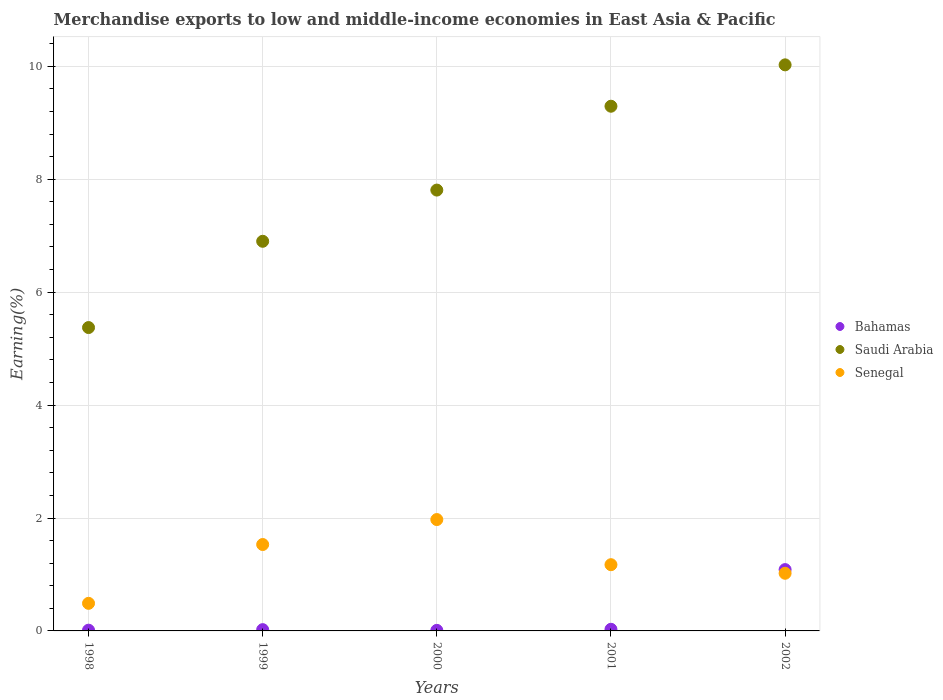Is the number of dotlines equal to the number of legend labels?
Provide a succinct answer. Yes. What is the percentage of amount earned from merchandise exports in Saudi Arabia in 2002?
Keep it short and to the point. 10.03. Across all years, what is the maximum percentage of amount earned from merchandise exports in Senegal?
Provide a succinct answer. 1.97. Across all years, what is the minimum percentage of amount earned from merchandise exports in Bahamas?
Give a very brief answer. 0.01. In which year was the percentage of amount earned from merchandise exports in Senegal minimum?
Your answer should be very brief. 1998. What is the total percentage of amount earned from merchandise exports in Bahamas in the graph?
Give a very brief answer. 1.16. What is the difference between the percentage of amount earned from merchandise exports in Bahamas in 1998 and that in 2002?
Keep it short and to the point. -1.07. What is the difference between the percentage of amount earned from merchandise exports in Bahamas in 2002 and the percentage of amount earned from merchandise exports in Saudi Arabia in 1999?
Provide a succinct answer. -5.81. What is the average percentage of amount earned from merchandise exports in Saudi Arabia per year?
Provide a succinct answer. 7.88. In the year 1999, what is the difference between the percentage of amount earned from merchandise exports in Saudi Arabia and percentage of amount earned from merchandise exports in Bahamas?
Offer a very short reply. 6.88. In how many years, is the percentage of amount earned from merchandise exports in Bahamas greater than 7.6 %?
Provide a succinct answer. 0. What is the ratio of the percentage of amount earned from merchandise exports in Senegal in 1999 to that in 2000?
Keep it short and to the point. 0.78. What is the difference between the highest and the second highest percentage of amount earned from merchandise exports in Senegal?
Your answer should be compact. 0.44. What is the difference between the highest and the lowest percentage of amount earned from merchandise exports in Senegal?
Make the answer very short. 1.48. In how many years, is the percentage of amount earned from merchandise exports in Bahamas greater than the average percentage of amount earned from merchandise exports in Bahamas taken over all years?
Provide a short and direct response. 1. Is the sum of the percentage of amount earned from merchandise exports in Senegal in 1998 and 2000 greater than the maximum percentage of amount earned from merchandise exports in Saudi Arabia across all years?
Provide a succinct answer. No. Does the percentage of amount earned from merchandise exports in Bahamas monotonically increase over the years?
Your response must be concise. No. Is the percentage of amount earned from merchandise exports in Senegal strictly greater than the percentage of amount earned from merchandise exports in Bahamas over the years?
Your answer should be compact. No. How many dotlines are there?
Make the answer very short. 3. How many years are there in the graph?
Provide a short and direct response. 5. What is the difference between two consecutive major ticks on the Y-axis?
Your response must be concise. 2. Does the graph contain grids?
Your answer should be very brief. Yes. Where does the legend appear in the graph?
Ensure brevity in your answer.  Center right. How many legend labels are there?
Offer a very short reply. 3. What is the title of the graph?
Offer a very short reply. Merchandise exports to low and middle-income economies in East Asia & Pacific. What is the label or title of the X-axis?
Keep it short and to the point. Years. What is the label or title of the Y-axis?
Ensure brevity in your answer.  Earning(%). What is the Earning(%) in Bahamas in 1998?
Provide a short and direct response. 0.01. What is the Earning(%) in Saudi Arabia in 1998?
Your response must be concise. 5.37. What is the Earning(%) in Senegal in 1998?
Provide a succinct answer. 0.49. What is the Earning(%) in Bahamas in 1999?
Make the answer very short. 0.02. What is the Earning(%) in Saudi Arabia in 1999?
Provide a short and direct response. 6.9. What is the Earning(%) of Senegal in 1999?
Provide a short and direct response. 1.53. What is the Earning(%) of Bahamas in 2000?
Provide a succinct answer. 0.01. What is the Earning(%) in Saudi Arabia in 2000?
Offer a terse response. 7.81. What is the Earning(%) of Senegal in 2000?
Ensure brevity in your answer.  1.97. What is the Earning(%) of Bahamas in 2001?
Your response must be concise. 0.03. What is the Earning(%) of Saudi Arabia in 2001?
Make the answer very short. 9.29. What is the Earning(%) in Senegal in 2001?
Your answer should be compact. 1.17. What is the Earning(%) of Bahamas in 2002?
Ensure brevity in your answer.  1.09. What is the Earning(%) of Saudi Arabia in 2002?
Your answer should be very brief. 10.03. What is the Earning(%) in Senegal in 2002?
Provide a succinct answer. 1.02. Across all years, what is the maximum Earning(%) of Bahamas?
Provide a succinct answer. 1.09. Across all years, what is the maximum Earning(%) of Saudi Arabia?
Provide a succinct answer. 10.03. Across all years, what is the maximum Earning(%) in Senegal?
Offer a very short reply. 1.97. Across all years, what is the minimum Earning(%) of Bahamas?
Offer a terse response. 0.01. Across all years, what is the minimum Earning(%) of Saudi Arabia?
Provide a succinct answer. 5.37. Across all years, what is the minimum Earning(%) of Senegal?
Your answer should be very brief. 0.49. What is the total Earning(%) of Bahamas in the graph?
Give a very brief answer. 1.16. What is the total Earning(%) of Saudi Arabia in the graph?
Ensure brevity in your answer.  39.4. What is the total Earning(%) of Senegal in the graph?
Keep it short and to the point. 6.19. What is the difference between the Earning(%) of Bahamas in 1998 and that in 1999?
Ensure brevity in your answer.  -0.01. What is the difference between the Earning(%) in Saudi Arabia in 1998 and that in 1999?
Keep it short and to the point. -1.53. What is the difference between the Earning(%) in Senegal in 1998 and that in 1999?
Offer a terse response. -1.04. What is the difference between the Earning(%) in Bahamas in 1998 and that in 2000?
Your answer should be compact. 0. What is the difference between the Earning(%) of Saudi Arabia in 1998 and that in 2000?
Provide a succinct answer. -2.43. What is the difference between the Earning(%) of Senegal in 1998 and that in 2000?
Keep it short and to the point. -1.48. What is the difference between the Earning(%) of Bahamas in 1998 and that in 2001?
Give a very brief answer. -0.02. What is the difference between the Earning(%) in Saudi Arabia in 1998 and that in 2001?
Give a very brief answer. -3.92. What is the difference between the Earning(%) in Senegal in 1998 and that in 2001?
Offer a terse response. -0.68. What is the difference between the Earning(%) in Bahamas in 1998 and that in 2002?
Offer a terse response. -1.07. What is the difference between the Earning(%) in Saudi Arabia in 1998 and that in 2002?
Provide a short and direct response. -4.65. What is the difference between the Earning(%) in Senegal in 1998 and that in 2002?
Make the answer very short. -0.53. What is the difference between the Earning(%) in Bahamas in 1999 and that in 2000?
Provide a succinct answer. 0.01. What is the difference between the Earning(%) of Saudi Arabia in 1999 and that in 2000?
Provide a short and direct response. -0.91. What is the difference between the Earning(%) in Senegal in 1999 and that in 2000?
Ensure brevity in your answer.  -0.44. What is the difference between the Earning(%) in Bahamas in 1999 and that in 2001?
Make the answer very short. -0.01. What is the difference between the Earning(%) of Saudi Arabia in 1999 and that in 2001?
Provide a short and direct response. -2.39. What is the difference between the Earning(%) of Senegal in 1999 and that in 2001?
Your answer should be very brief. 0.36. What is the difference between the Earning(%) in Bahamas in 1999 and that in 2002?
Make the answer very short. -1.06. What is the difference between the Earning(%) of Saudi Arabia in 1999 and that in 2002?
Your response must be concise. -3.12. What is the difference between the Earning(%) of Senegal in 1999 and that in 2002?
Ensure brevity in your answer.  0.51. What is the difference between the Earning(%) in Bahamas in 2000 and that in 2001?
Your answer should be compact. -0.02. What is the difference between the Earning(%) of Saudi Arabia in 2000 and that in 2001?
Offer a very short reply. -1.49. What is the difference between the Earning(%) of Senegal in 2000 and that in 2001?
Your answer should be very brief. 0.8. What is the difference between the Earning(%) in Bahamas in 2000 and that in 2002?
Ensure brevity in your answer.  -1.08. What is the difference between the Earning(%) in Saudi Arabia in 2000 and that in 2002?
Provide a short and direct response. -2.22. What is the difference between the Earning(%) of Senegal in 2000 and that in 2002?
Provide a succinct answer. 0.95. What is the difference between the Earning(%) of Bahamas in 2001 and that in 2002?
Offer a very short reply. -1.06. What is the difference between the Earning(%) of Saudi Arabia in 2001 and that in 2002?
Give a very brief answer. -0.73. What is the difference between the Earning(%) of Senegal in 2001 and that in 2002?
Your answer should be compact. 0.15. What is the difference between the Earning(%) in Bahamas in 1998 and the Earning(%) in Saudi Arabia in 1999?
Your response must be concise. -6.89. What is the difference between the Earning(%) in Bahamas in 1998 and the Earning(%) in Senegal in 1999?
Offer a terse response. -1.52. What is the difference between the Earning(%) of Saudi Arabia in 1998 and the Earning(%) of Senegal in 1999?
Give a very brief answer. 3.84. What is the difference between the Earning(%) of Bahamas in 1998 and the Earning(%) of Saudi Arabia in 2000?
Make the answer very short. -7.79. What is the difference between the Earning(%) in Bahamas in 1998 and the Earning(%) in Senegal in 2000?
Give a very brief answer. -1.96. What is the difference between the Earning(%) in Saudi Arabia in 1998 and the Earning(%) in Senegal in 2000?
Your answer should be compact. 3.4. What is the difference between the Earning(%) in Bahamas in 1998 and the Earning(%) in Saudi Arabia in 2001?
Provide a short and direct response. -9.28. What is the difference between the Earning(%) in Bahamas in 1998 and the Earning(%) in Senegal in 2001?
Your response must be concise. -1.16. What is the difference between the Earning(%) in Saudi Arabia in 1998 and the Earning(%) in Senegal in 2001?
Provide a succinct answer. 4.2. What is the difference between the Earning(%) of Bahamas in 1998 and the Earning(%) of Saudi Arabia in 2002?
Provide a succinct answer. -10.01. What is the difference between the Earning(%) of Bahamas in 1998 and the Earning(%) of Senegal in 2002?
Make the answer very short. -1.01. What is the difference between the Earning(%) of Saudi Arabia in 1998 and the Earning(%) of Senegal in 2002?
Ensure brevity in your answer.  4.35. What is the difference between the Earning(%) in Bahamas in 1999 and the Earning(%) in Saudi Arabia in 2000?
Your answer should be compact. -7.79. What is the difference between the Earning(%) in Bahamas in 1999 and the Earning(%) in Senegal in 2000?
Your answer should be compact. -1.95. What is the difference between the Earning(%) of Saudi Arabia in 1999 and the Earning(%) of Senegal in 2000?
Ensure brevity in your answer.  4.93. What is the difference between the Earning(%) in Bahamas in 1999 and the Earning(%) in Saudi Arabia in 2001?
Provide a short and direct response. -9.27. What is the difference between the Earning(%) of Bahamas in 1999 and the Earning(%) of Senegal in 2001?
Offer a terse response. -1.15. What is the difference between the Earning(%) of Saudi Arabia in 1999 and the Earning(%) of Senegal in 2001?
Provide a succinct answer. 5.73. What is the difference between the Earning(%) in Bahamas in 1999 and the Earning(%) in Saudi Arabia in 2002?
Offer a very short reply. -10. What is the difference between the Earning(%) in Bahamas in 1999 and the Earning(%) in Senegal in 2002?
Ensure brevity in your answer.  -1. What is the difference between the Earning(%) in Saudi Arabia in 1999 and the Earning(%) in Senegal in 2002?
Your response must be concise. 5.88. What is the difference between the Earning(%) of Bahamas in 2000 and the Earning(%) of Saudi Arabia in 2001?
Your response must be concise. -9.28. What is the difference between the Earning(%) in Bahamas in 2000 and the Earning(%) in Senegal in 2001?
Keep it short and to the point. -1.16. What is the difference between the Earning(%) of Saudi Arabia in 2000 and the Earning(%) of Senegal in 2001?
Offer a terse response. 6.64. What is the difference between the Earning(%) in Bahamas in 2000 and the Earning(%) in Saudi Arabia in 2002?
Provide a short and direct response. -10.02. What is the difference between the Earning(%) in Bahamas in 2000 and the Earning(%) in Senegal in 2002?
Provide a short and direct response. -1.01. What is the difference between the Earning(%) of Saudi Arabia in 2000 and the Earning(%) of Senegal in 2002?
Keep it short and to the point. 6.79. What is the difference between the Earning(%) of Bahamas in 2001 and the Earning(%) of Saudi Arabia in 2002?
Ensure brevity in your answer.  -10. What is the difference between the Earning(%) of Bahamas in 2001 and the Earning(%) of Senegal in 2002?
Make the answer very short. -0.99. What is the difference between the Earning(%) in Saudi Arabia in 2001 and the Earning(%) in Senegal in 2002?
Make the answer very short. 8.27. What is the average Earning(%) of Bahamas per year?
Offer a very short reply. 0.23. What is the average Earning(%) in Saudi Arabia per year?
Provide a short and direct response. 7.88. What is the average Earning(%) of Senegal per year?
Provide a short and direct response. 1.24. In the year 1998, what is the difference between the Earning(%) in Bahamas and Earning(%) in Saudi Arabia?
Your answer should be very brief. -5.36. In the year 1998, what is the difference between the Earning(%) in Bahamas and Earning(%) in Senegal?
Provide a succinct answer. -0.48. In the year 1998, what is the difference between the Earning(%) in Saudi Arabia and Earning(%) in Senegal?
Your response must be concise. 4.88. In the year 1999, what is the difference between the Earning(%) of Bahamas and Earning(%) of Saudi Arabia?
Give a very brief answer. -6.88. In the year 1999, what is the difference between the Earning(%) in Bahamas and Earning(%) in Senegal?
Make the answer very short. -1.51. In the year 1999, what is the difference between the Earning(%) of Saudi Arabia and Earning(%) of Senegal?
Give a very brief answer. 5.37. In the year 2000, what is the difference between the Earning(%) in Bahamas and Earning(%) in Saudi Arabia?
Give a very brief answer. -7.8. In the year 2000, what is the difference between the Earning(%) in Bahamas and Earning(%) in Senegal?
Your answer should be very brief. -1.96. In the year 2000, what is the difference between the Earning(%) of Saudi Arabia and Earning(%) of Senegal?
Keep it short and to the point. 5.84. In the year 2001, what is the difference between the Earning(%) in Bahamas and Earning(%) in Saudi Arabia?
Provide a short and direct response. -9.26. In the year 2001, what is the difference between the Earning(%) in Bahamas and Earning(%) in Senegal?
Make the answer very short. -1.14. In the year 2001, what is the difference between the Earning(%) of Saudi Arabia and Earning(%) of Senegal?
Make the answer very short. 8.12. In the year 2002, what is the difference between the Earning(%) of Bahamas and Earning(%) of Saudi Arabia?
Ensure brevity in your answer.  -8.94. In the year 2002, what is the difference between the Earning(%) in Bahamas and Earning(%) in Senegal?
Your answer should be very brief. 0.07. In the year 2002, what is the difference between the Earning(%) of Saudi Arabia and Earning(%) of Senegal?
Ensure brevity in your answer.  9.01. What is the ratio of the Earning(%) in Bahamas in 1998 to that in 1999?
Keep it short and to the point. 0.58. What is the ratio of the Earning(%) of Saudi Arabia in 1998 to that in 1999?
Your answer should be compact. 0.78. What is the ratio of the Earning(%) of Senegal in 1998 to that in 1999?
Give a very brief answer. 0.32. What is the ratio of the Earning(%) in Bahamas in 1998 to that in 2000?
Give a very brief answer. 1.32. What is the ratio of the Earning(%) in Saudi Arabia in 1998 to that in 2000?
Provide a succinct answer. 0.69. What is the ratio of the Earning(%) of Senegal in 1998 to that in 2000?
Offer a terse response. 0.25. What is the ratio of the Earning(%) of Bahamas in 1998 to that in 2001?
Your response must be concise. 0.45. What is the ratio of the Earning(%) of Saudi Arabia in 1998 to that in 2001?
Your answer should be compact. 0.58. What is the ratio of the Earning(%) of Senegal in 1998 to that in 2001?
Offer a very short reply. 0.42. What is the ratio of the Earning(%) in Bahamas in 1998 to that in 2002?
Your answer should be very brief. 0.01. What is the ratio of the Earning(%) of Saudi Arabia in 1998 to that in 2002?
Make the answer very short. 0.54. What is the ratio of the Earning(%) of Senegal in 1998 to that in 2002?
Your answer should be compact. 0.48. What is the ratio of the Earning(%) in Bahamas in 1999 to that in 2000?
Ensure brevity in your answer.  2.27. What is the ratio of the Earning(%) of Saudi Arabia in 1999 to that in 2000?
Give a very brief answer. 0.88. What is the ratio of the Earning(%) of Senegal in 1999 to that in 2000?
Provide a short and direct response. 0.78. What is the ratio of the Earning(%) in Bahamas in 1999 to that in 2001?
Provide a succinct answer. 0.78. What is the ratio of the Earning(%) of Saudi Arabia in 1999 to that in 2001?
Offer a terse response. 0.74. What is the ratio of the Earning(%) in Senegal in 1999 to that in 2001?
Provide a short and direct response. 1.3. What is the ratio of the Earning(%) of Bahamas in 1999 to that in 2002?
Your answer should be very brief. 0.02. What is the ratio of the Earning(%) in Saudi Arabia in 1999 to that in 2002?
Your response must be concise. 0.69. What is the ratio of the Earning(%) in Senegal in 1999 to that in 2002?
Your answer should be very brief. 1.5. What is the ratio of the Earning(%) of Bahamas in 2000 to that in 2001?
Your answer should be compact. 0.34. What is the ratio of the Earning(%) in Saudi Arabia in 2000 to that in 2001?
Provide a succinct answer. 0.84. What is the ratio of the Earning(%) of Senegal in 2000 to that in 2001?
Offer a terse response. 1.68. What is the ratio of the Earning(%) in Bahamas in 2000 to that in 2002?
Offer a terse response. 0.01. What is the ratio of the Earning(%) of Saudi Arabia in 2000 to that in 2002?
Provide a short and direct response. 0.78. What is the ratio of the Earning(%) of Senegal in 2000 to that in 2002?
Give a very brief answer. 1.93. What is the ratio of the Earning(%) of Bahamas in 2001 to that in 2002?
Your response must be concise. 0.03. What is the ratio of the Earning(%) in Saudi Arabia in 2001 to that in 2002?
Keep it short and to the point. 0.93. What is the ratio of the Earning(%) in Senegal in 2001 to that in 2002?
Provide a succinct answer. 1.15. What is the difference between the highest and the second highest Earning(%) of Bahamas?
Your answer should be very brief. 1.06. What is the difference between the highest and the second highest Earning(%) of Saudi Arabia?
Make the answer very short. 0.73. What is the difference between the highest and the second highest Earning(%) of Senegal?
Offer a terse response. 0.44. What is the difference between the highest and the lowest Earning(%) in Bahamas?
Provide a succinct answer. 1.08. What is the difference between the highest and the lowest Earning(%) of Saudi Arabia?
Your answer should be compact. 4.65. What is the difference between the highest and the lowest Earning(%) in Senegal?
Ensure brevity in your answer.  1.48. 